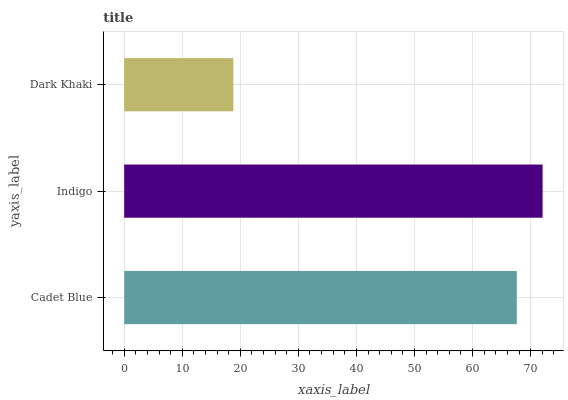Is Dark Khaki the minimum?
Answer yes or no. Yes. Is Indigo the maximum?
Answer yes or no. Yes. Is Indigo the minimum?
Answer yes or no. No. Is Dark Khaki the maximum?
Answer yes or no. No. Is Indigo greater than Dark Khaki?
Answer yes or no. Yes. Is Dark Khaki less than Indigo?
Answer yes or no. Yes. Is Dark Khaki greater than Indigo?
Answer yes or no. No. Is Indigo less than Dark Khaki?
Answer yes or no. No. Is Cadet Blue the high median?
Answer yes or no. Yes. Is Cadet Blue the low median?
Answer yes or no. Yes. Is Indigo the high median?
Answer yes or no. No. Is Indigo the low median?
Answer yes or no. No. 